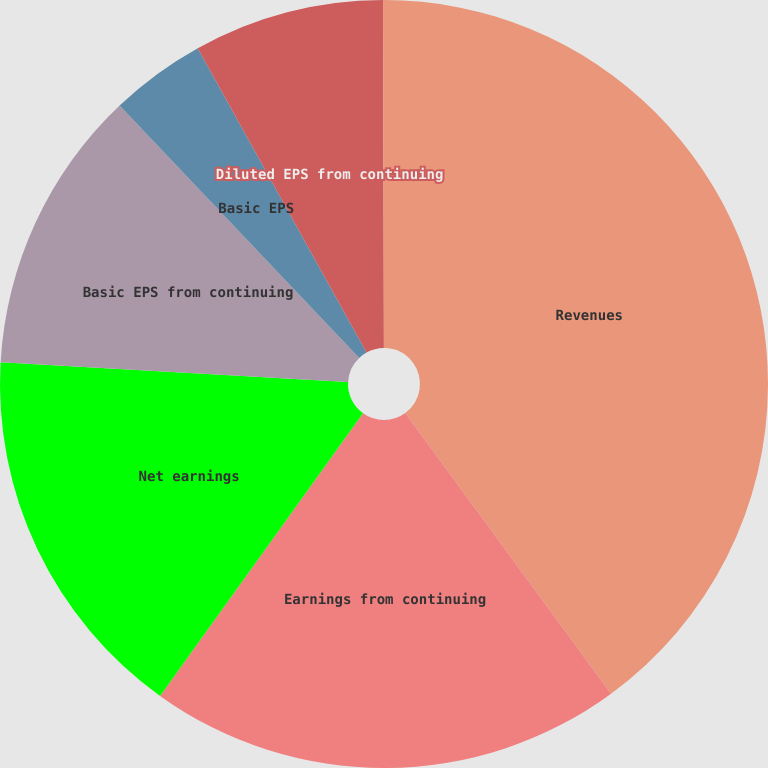Convert chart to OTSL. <chart><loc_0><loc_0><loc_500><loc_500><pie_chart><fcel>Revenues<fcel>Earnings from continuing<fcel>Net earnings<fcel>Basic EPS from continuing<fcel>Basic EPS<fcel>Diluted EPS from continuing<fcel>Diluted EPS<nl><fcel>39.93%<fcel>19.98%<fcel>15.99%<fcel>12.01%<fcel>4.03%<fcel>8.02%<fcel>0.04%<nl></chart> 